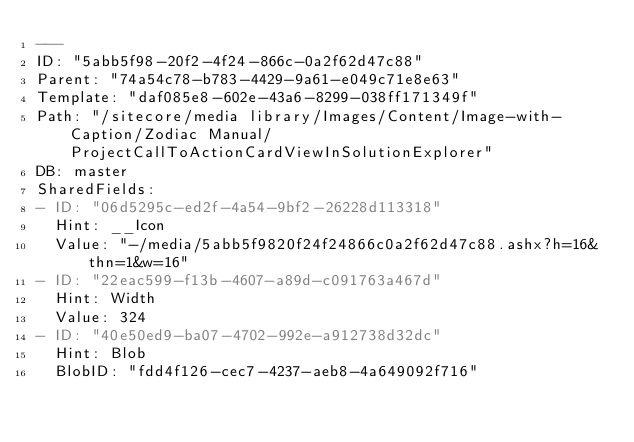Convert code to text. <code><loc_0><loc_0><loc_500><loc_500><_YAML_>---
ID: "5abb5f98-20f2-4f24-866c-0a2f62d47c88"
Parent: "74a54c78-b783-4429-9a61-e049c71e8e63"
Template: "daf085e8-602e-43a6-8299-038ff171349f"
Path: "/sitecore/media library/Images/Content/Image-with-Caption/Zodiac Manual/ProjectCallToActionCardViewInSolutionExplorer"
DB: master
SharedFields:
- ID: "06d5295c-ed2f-4a54-9bf2-26228d113318"
  Hint: __Icon
  Value: "-/media/5abb5f9820f24f24866c0a2f62d47c88.ashx?h=16&thn=1&w=16"
- ID: "22eac599-f13b-4607-a89d-c091763a467d"
  Hint: Width
  Value: 324
- ID: "40e50ed9-ba07-4702-992e-a912738d32dc"
  Hint: Blob
  BlobID: "fdd4f126-cec7-4237-aeb8-4a649092f716"</code> 